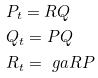<formula> <loc_0><loc_0><loc_500><loc_500>& P _ { t } = R Q \\ & Q _ { t } = P Q \\ & R _ { t } = \ g a R P</formula> 